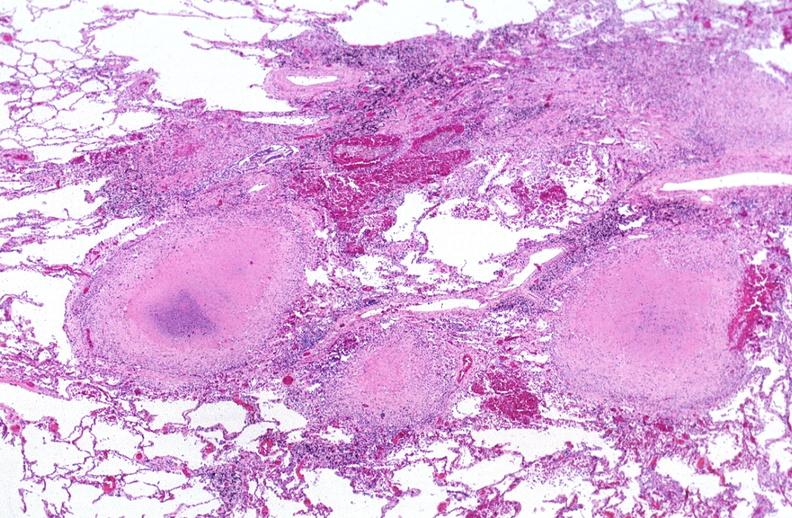s morphology present?
Answer the question using a single word or phrase. No 